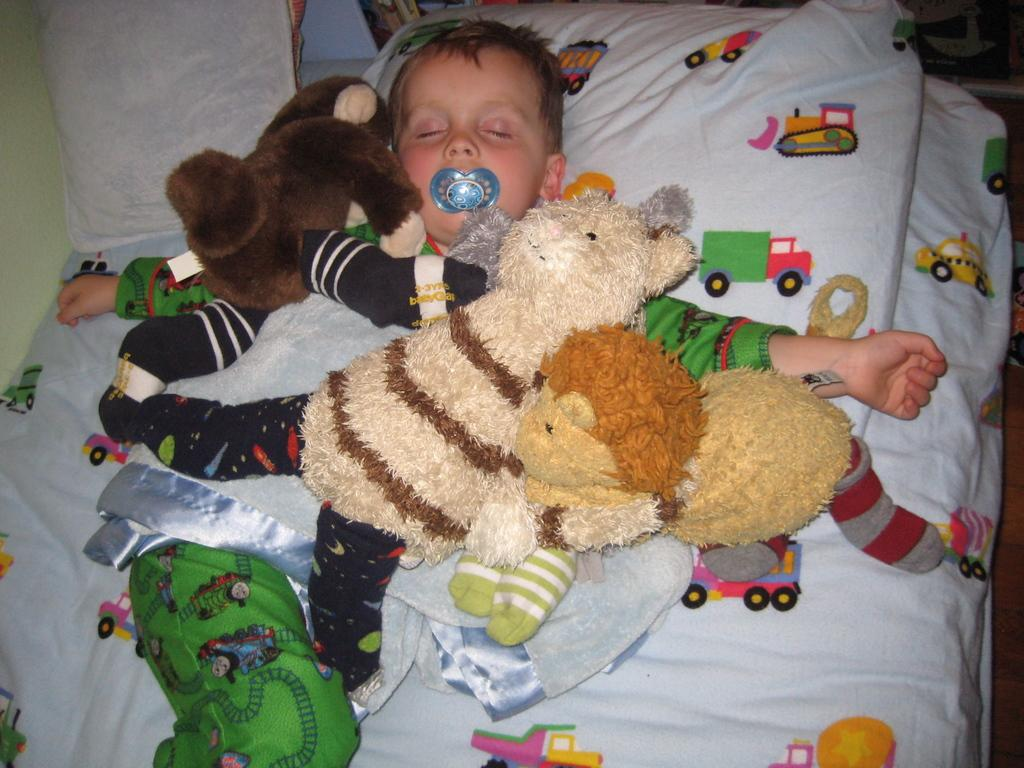Who is in the image? There is a boy in the image. What is the boy doing in the image? The boy is sleeping on the bed. What is on top of the boy in the image? There are toys on top of the boy. What else can be seen on the bed in the image? There are pillows on the bed. What story is the boy reading in the image? There is no story visible in the image, as the boy is sleeping and not reading. 